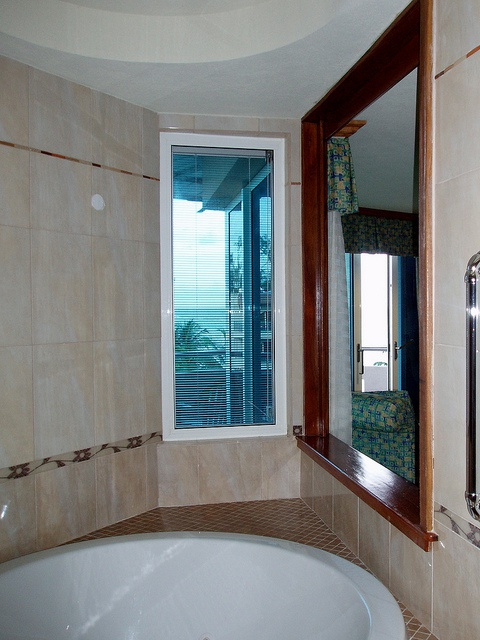Describe the objects in this image and their specific colors. I can see a couch in gray, black, teal, and darkgreen tones in this image. 